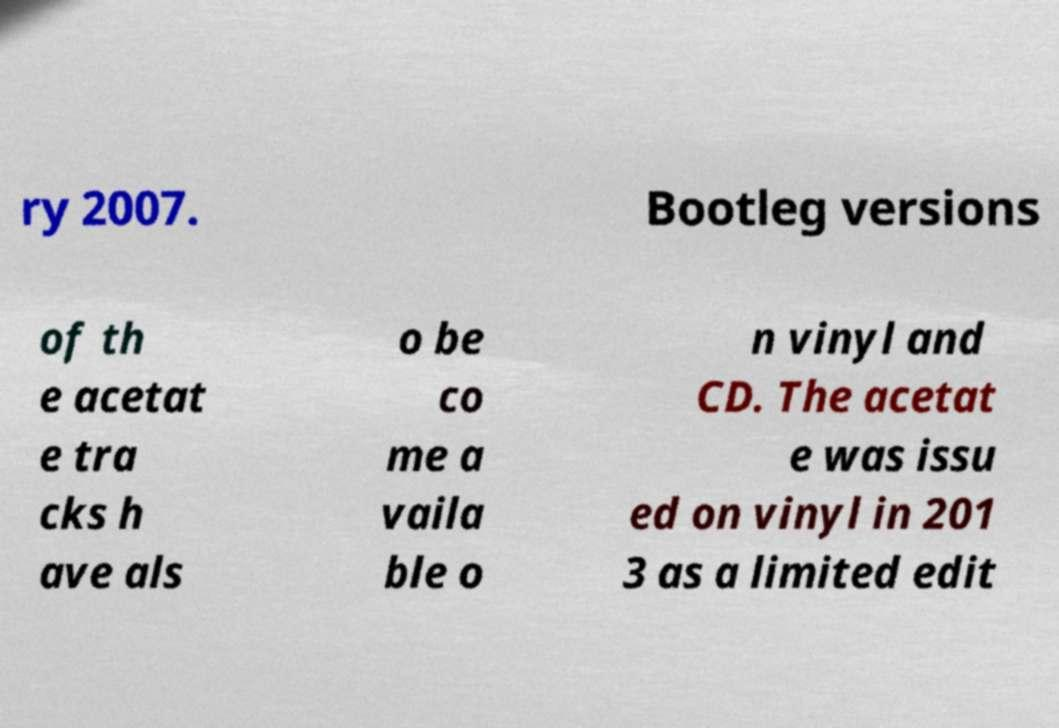Can you accurately transcribe the text from the provided image for me? ry 2007. Bootleg versions of th e acetat e tra cks h ave als o be co me a vaila ble o n vinyl and CD. The acetat e was issu ed on vinyl in 201 3 as a limited edit 